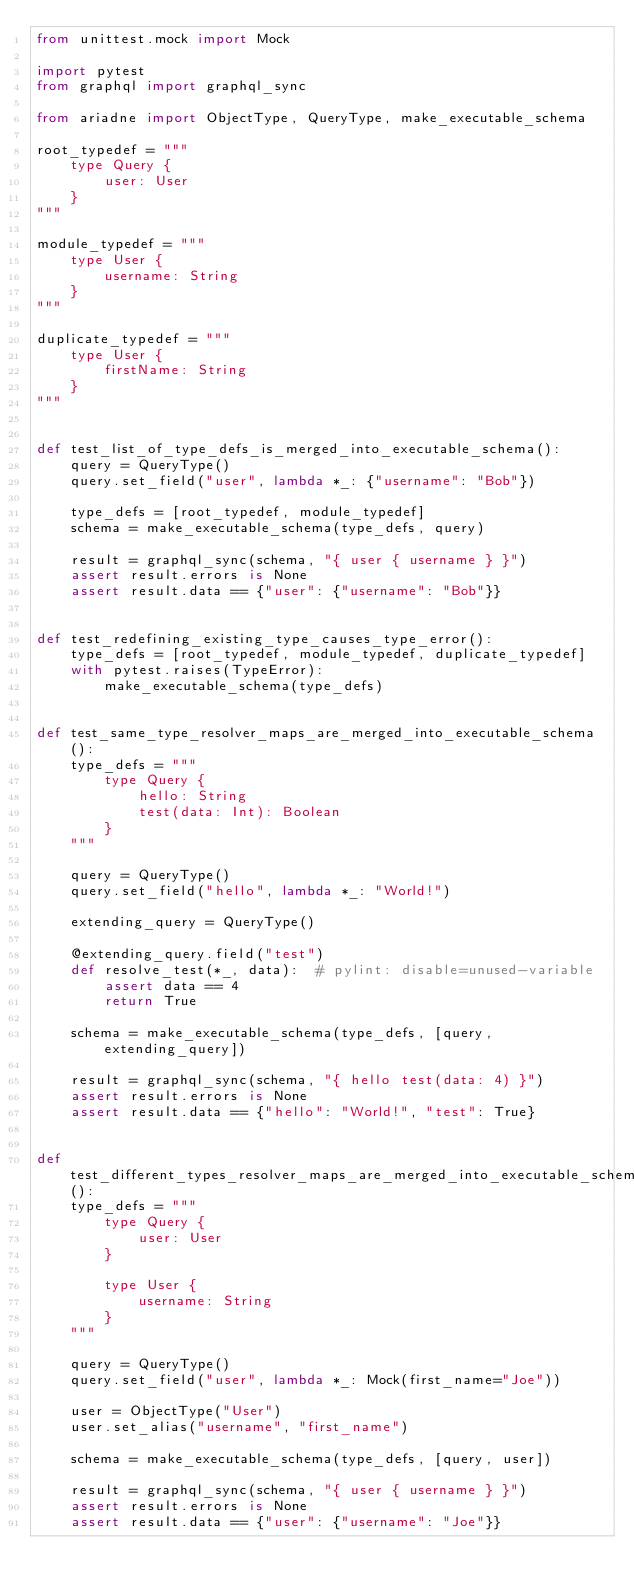<code> <loc_0><loc_0><loc_500><loc_500><_Python_>from unittest.mock import Mock

import pytest
from graphql import graphql_sync

from ariadne import ObjectType, QueryType, make_executable_schema

root_typedef = """
    type Query {
        user: User
    }
"""

module_typedef = """
    type User {
        username: String
    }
"""

duplicate_typedef = """
    type User {
        firstName: String
    }
"""


def test_list_of_type_defs_is_merged_into_executable_schema():
    query = QueryType()
    query.set_field("user", lambda *_: {"username": "Bob"})

    type_defs = [root_typedef, module_typedef]
    schema = make_executable_schema(type_defs, query)

    result = graphql_sync(schema, "{ user { username } }")
    assert result.errors is None
    assert result.data == {"user": {"username": "Bob"}}


def test_redefining_existing_type_causes_type_error():
    type_defs = [root_typedef, module_typedef, duplicate_typedef]
    with pytest.raises(TypeError):
        make_executable_schema(type_defs)


def test_same_type_resolver_maps_are_merged_into_executable_schema():
    type_defs = """
        type Query {
            hello: String
            test(data: Int): Boolean
        }
    """

    query = QueryType()
    query.set_field("hello", lambda *_: "World!")

    extending_query = QueryType()

    @extending_query.field("test")
    def resolve_test(*_, data):  # pylint: disable=unused-variable
        assert data == 4
        return True

    schema = make_executable_schema(type_defs, [query, extending_query])

    result = graphql_sync(schema, "{ hello test(data: 4) }")
    assert result.errors is None
    assert result.data == {"hello": "World!", "test": True}


def test_different_types_resolver_maps_are_merged_into_executable_schema():
    type_defs = """
        type Query {
            user: User
        }

        type User {
            username: String
        }
    """

    query = QueryType()
    query.set_field("user", lambda *_: Mock(first_name="Joe"))

    user = ObjectType("User")
    user.set_alias("username", "first_name")

    schema = make_executable_schema(type_defs, [query, user])

    result = graphql_sync(schema, "{ user { username } }")
    assert result.errors is None
    assert result.data == {"user": {"username": "Joe"}}
</code> 